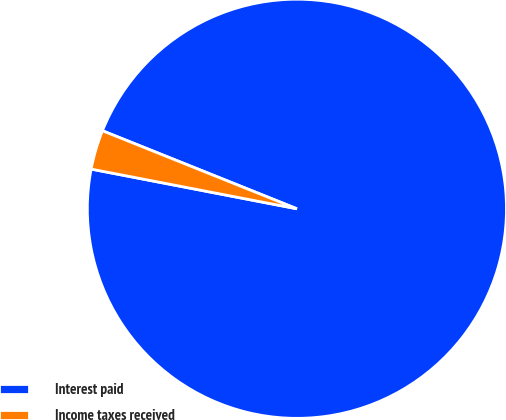Convert chart. <chart><loc_0><loc_0><loc_500><loc_500><pie_chart><fcel>Interest paid<fcel>Income taxes received<nl><fcel>96.96%<fcel>3.04%<nl></chart> 